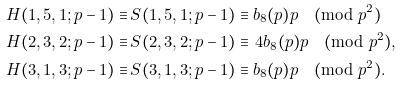<formula> <loc_0><loc_0><loc_500><loc_500>H ( 1 , 5 , 1 ; p - 1 ) \equiv & \, S ( 1 , 5 , 1 ; p - 1 ) \equiv b _ { 8 } ( p ) p \pmod { p ^ { 2 } } \\ H ( 2 , 3 , 2 ; p - 1 ) \equiv & \, S ( 2 , 3 , 2 ; p - 1 ) \equiv \, 4 b _ { 8 } ( p ) p \pmod { p ^ { 2 } } , \\ H ( 3 , 1 , 3 ; p - 1 ) \equiv & \, S ( 3 , 1 , 3 ; p - 1 ) \equiv b _ { 8 } ( p ) p \pmod { p ^ { 2 } } .</formula> 